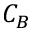<formula> <loc_0><loc_0><loc_500><loc_500>C _ { B }</formula> 